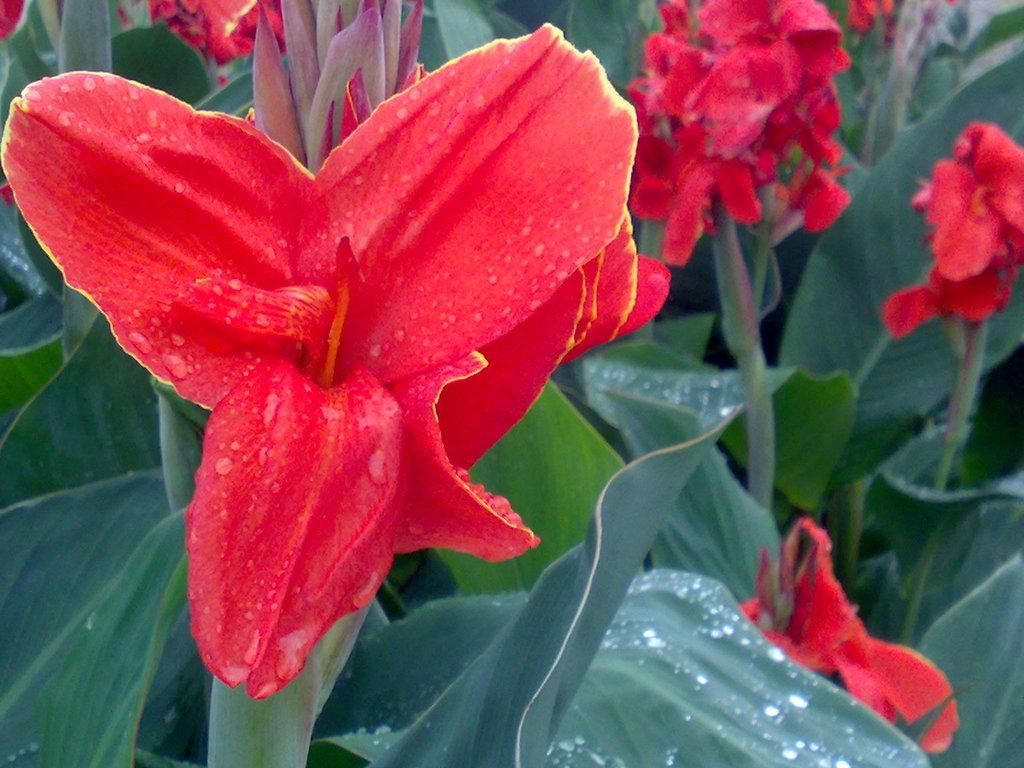Where was the image likely taken? The image appears to be taken outside. What can be seen in the foreground of the image? There are flowers and green leaves of plants in the foreground of the image. Can you describe the object at the top of the image? There is an object at the top of the image that resembles a bud. What type of lettuce is being used as a chin rest in the image? There is no lettuce or chin rest present in the image. 